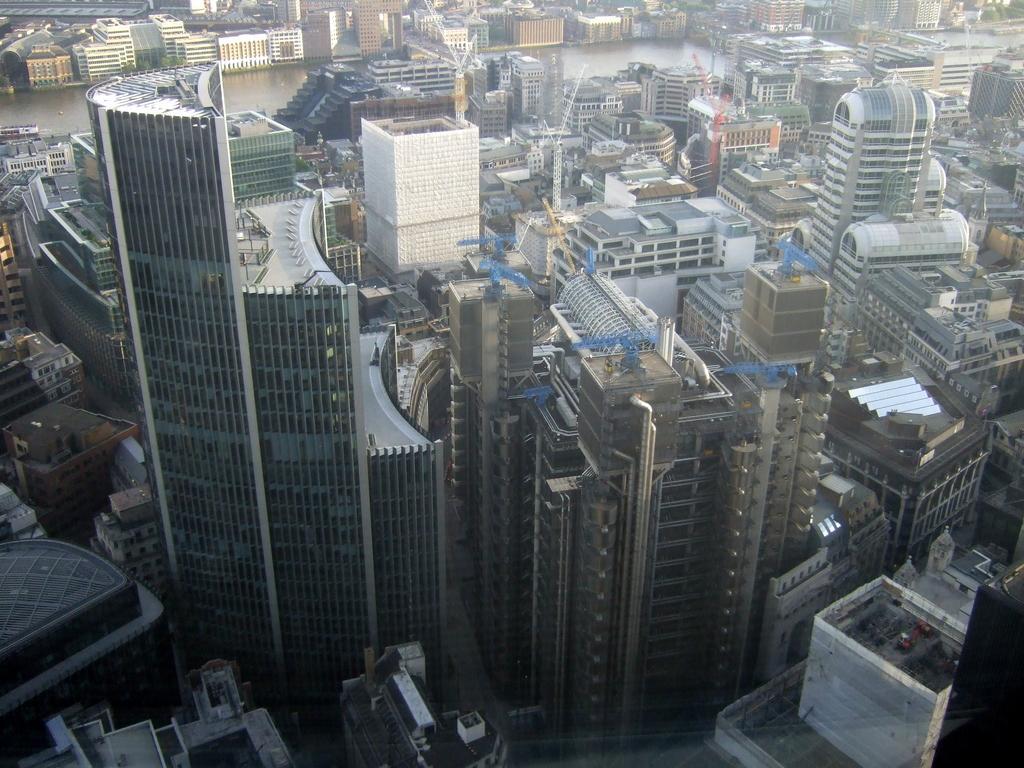How would you summarize this image in a sentence or two? The image is aerial view of a city. In the foreground of the picture there are skyscrapers and buildings. In the background there is a water body. At the top there are buildings. 